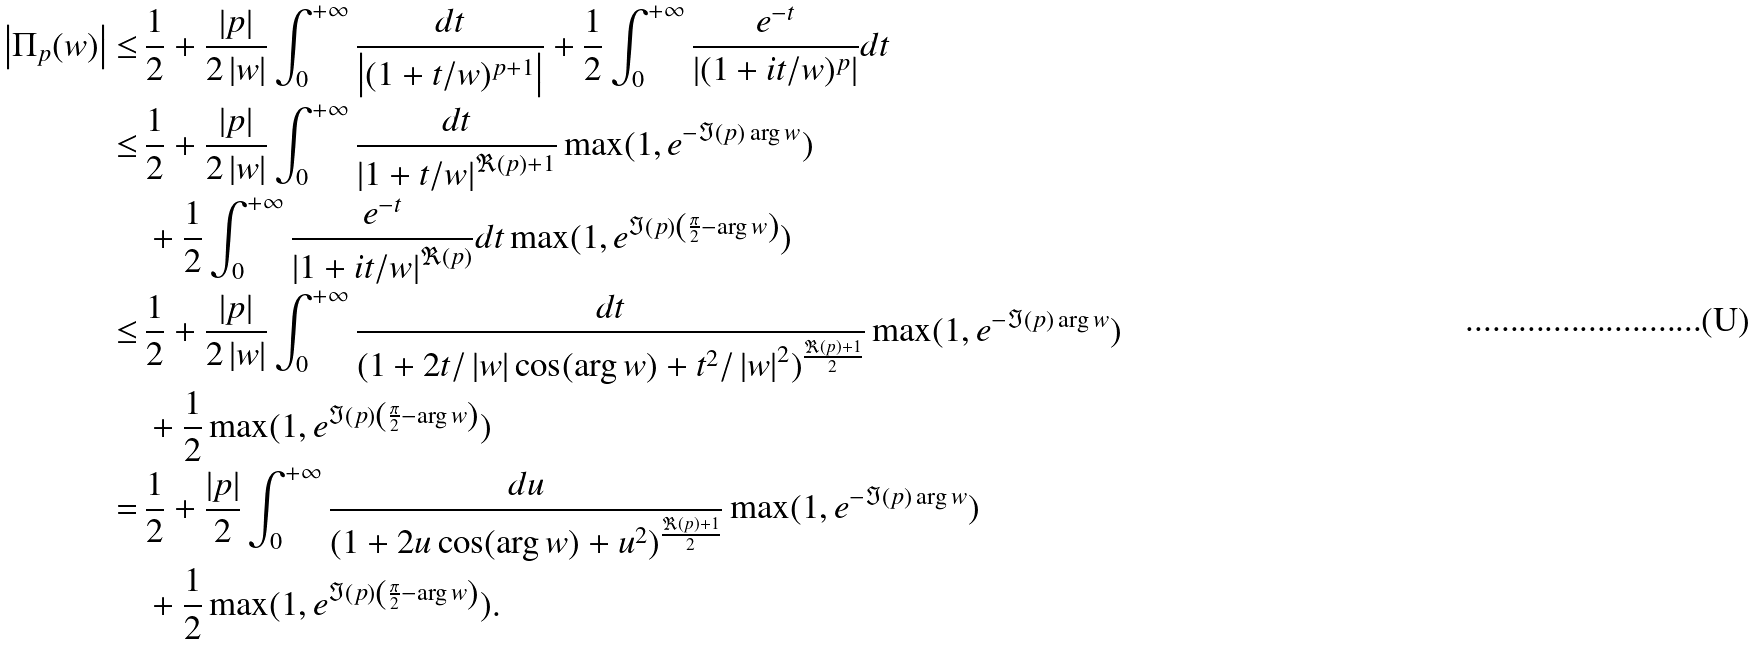<formula> <loc_0><loc_0><loc_500><loc_500>\left | { \Pi _ { p } ( w ) } \right | \leq \, & \frac { 1 } { 2 } + \frac { \left | p \right | } { 2 \left | w \right | } \int _ { 0 } ^ { + \infty } { \frac { d t } { { \left | { ( 1 + t / w ) ^ { p + 1 } } \right | } } } + \frac { 1 } { 2 } \int _ { 0 } ^ { + \infty } { \frac { { e ^ { - t } } } { { \left | { ( 1 + i t / w ) ^ { p } } \right | } } d t } \\ \leq \, & \frac { 1 } { 2 } + \frac { \left | p \right | } { 2 \left | w \right | } \int _ { 0 } ^ { + \infty } { \frac { d t } { { \left | { 1 + t / w } \right | ^ { \Re ( p ) + 1 } } } } \max ( 1 , e ^ { - \Im ( p ) \arg w } ) \\ & + \frac { 1 } { 2 } \int _ { 0 } ^ { + \infty } { \frac { { e ^ { - t } } } { { \left | { 1 + i t / w } \right | ^ { \Re ( p ) } } } d t } \max ( 1 , e ^ { \Im ( p ) \left ( { \frac { \pi } { 2 } - \arg w } \right ) } ) \\ \leq \, & \frac { 1 } { 2 } + \frac { \left | p \right | } { 2 \left | w \right | } \int _ { 0 } ^ { + \infty } { \frac { d t } { { ( 1 + 2 t / \left | w \right | \cos ( \arg w ) + t ^ { 2 } / \left | w \right | ^ { 2 } ) ^ { \frac { \Re ( p ) + 1 } { 2 } } } } } \max ( 1 , e ^ { - \Im ( p ) \arg w } ) \\ & + \frac { 1 } { 2 } \max ( 1 , e ^ { \Im ( p ) \left ( { \frac { \pi } { 2 } - \arg w } \right ) } ) \\ = \, & \frac { 1 } { 2 } + \frac { \left | p \right | } { 2 } \int _ { 0 } ^ { + \infty } { \frac { d u } { { ( 1 + 2 u \cos ( \arg w ) + u ^ { 2 } ) ^ { \frac { \Re ( p ) + 1 } { 2 } } } } } \max ( 1 , e ^ { - \Im ( p ) \arg w } ) \\ & + \frac { 1 } { 2 } \max ( 1 , e ^ { \Im ( p ) \left ( { \frac { \pi } { 2 } - \arg w } \right ) } ) .</formula> 